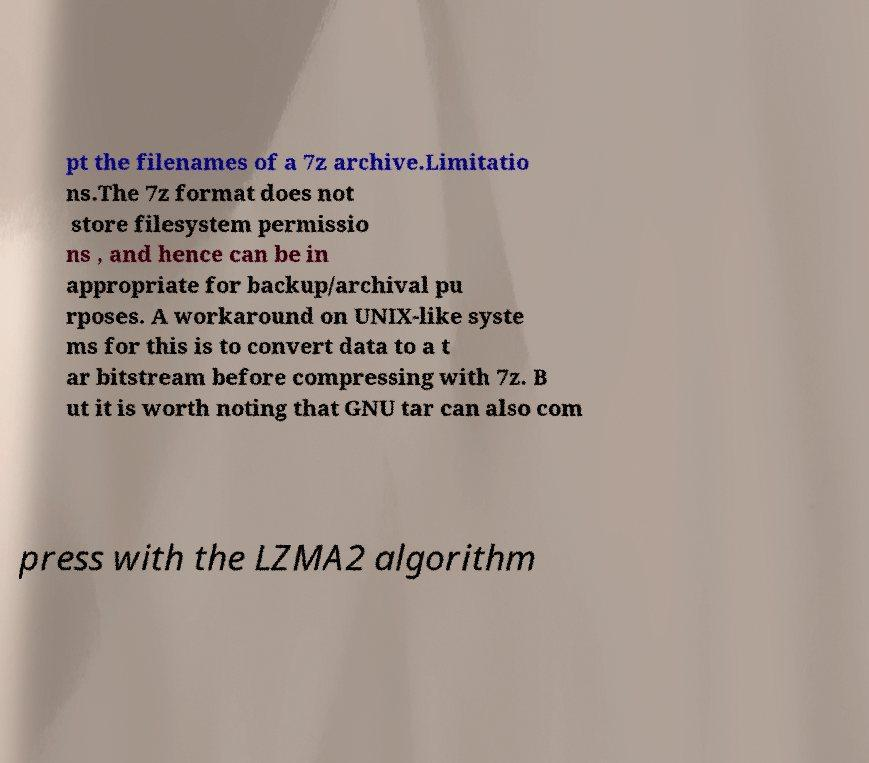There's text embedded in this image that I need extracted. Can you transcribe it verbatim? pt the filenames of a 7z archive.Limitatio ns.The 7z format does not store filesystem permissio ns , and hence can be in appropriate for backup/archival pu rposes. A workaround on UNIX-like syste ms for this is to convert data to a t ar bitstream before compressing with 7z. B ut it is worth noting that GNU tar can also com press with the LZMA2 algorithm 